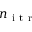Convert formula to latex. <formula><loc_0><loc_0><loc_500><loc_500>n _ { i t r }</formula> 